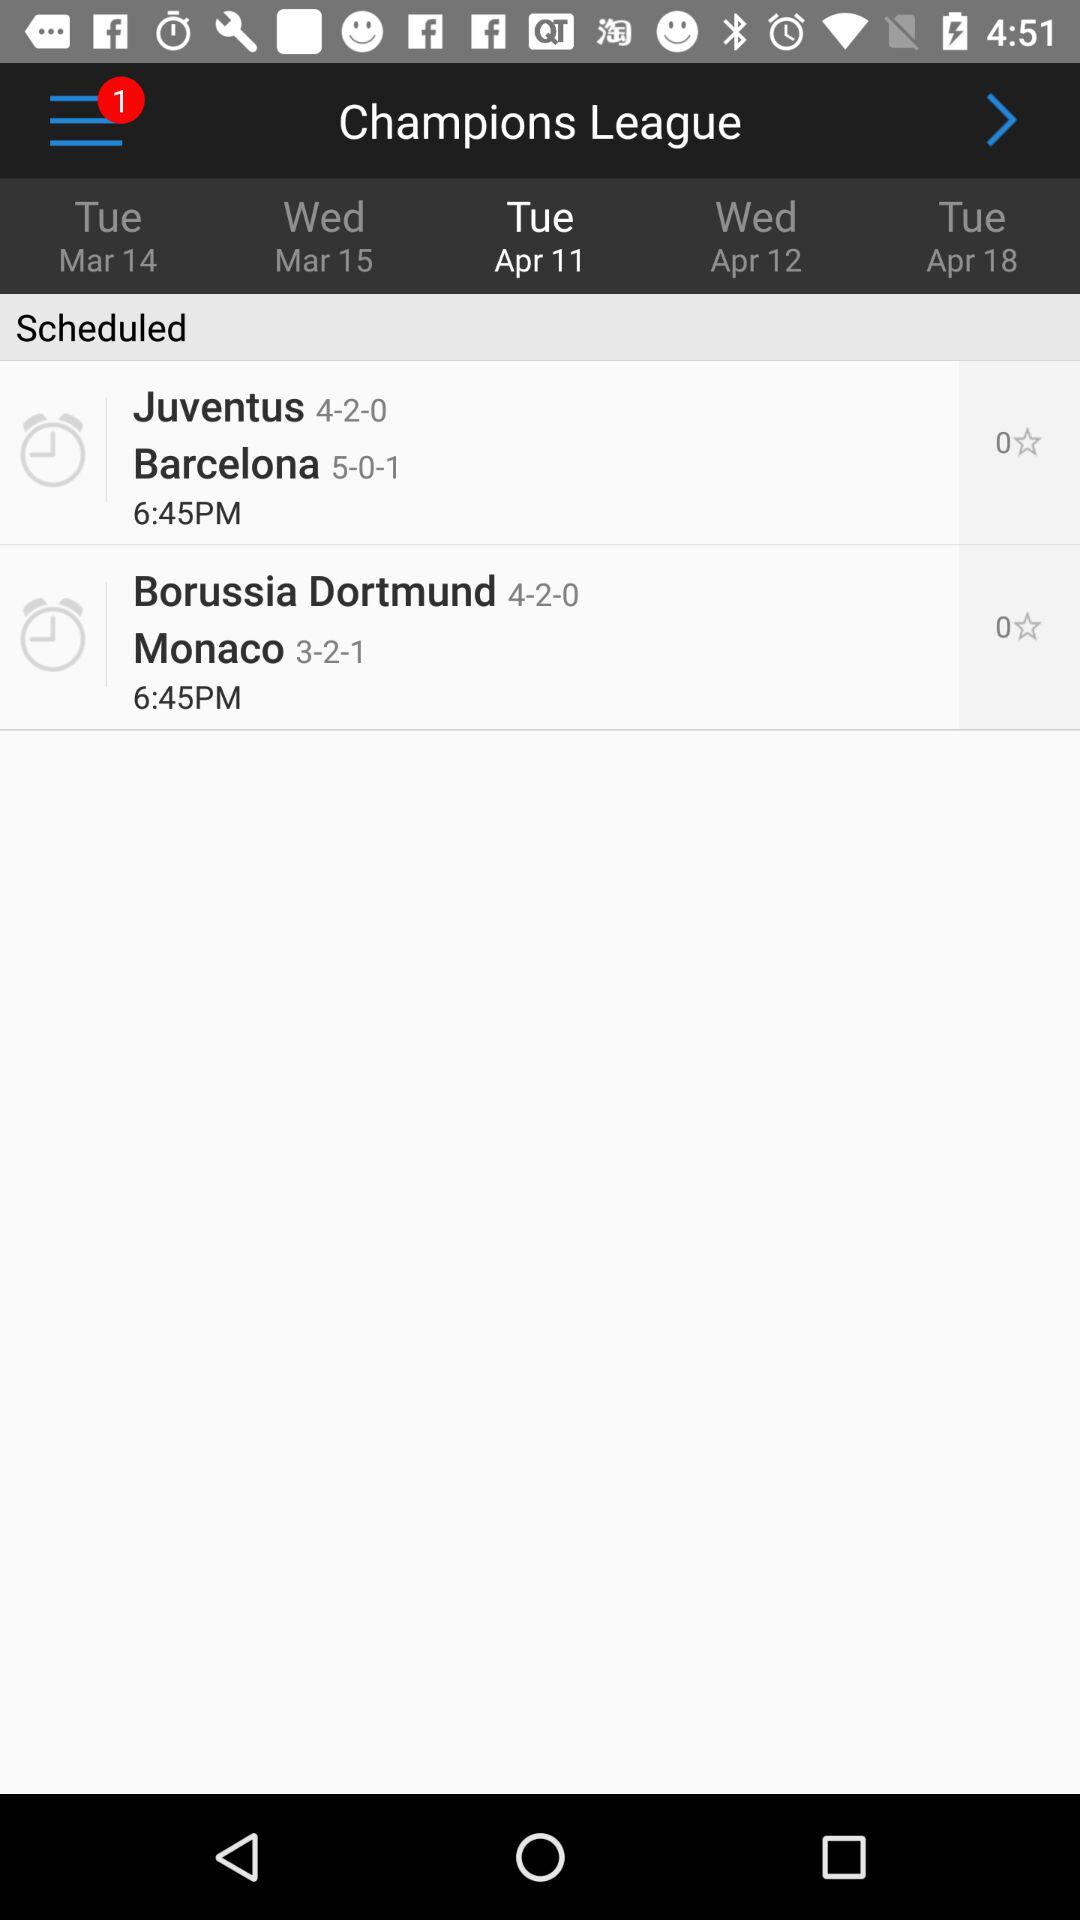What is the day on April 11? The day is Tuesday. 